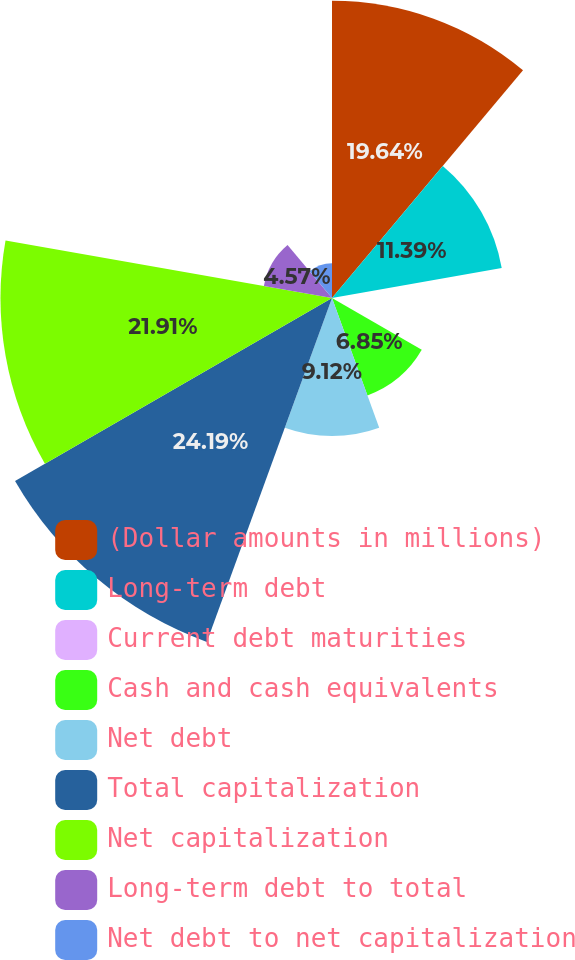Convert chart to OTSL. <chart><loc_0><loc_0><loc_500><loc_500><pie_chart><fcel>(Dollar amounts in millions)<fcel>Long-term debt<fcel>Current debt maturities<fcel>Cash and cash equivalents<fcel>Net debt<fcel>Total capitalization<fcel>Net capitalization<fcel>Long-term debt to total<fcel>Net debt to net capitalization<nl><fcel>19.64%<fcel>11.39%<fcel>0.03%<fcel>6.85%<fcel>9.12%<fcel>24.19%<fcel>21.91%<fcel>4.57%<fcel>2.3%<nl></chart> 